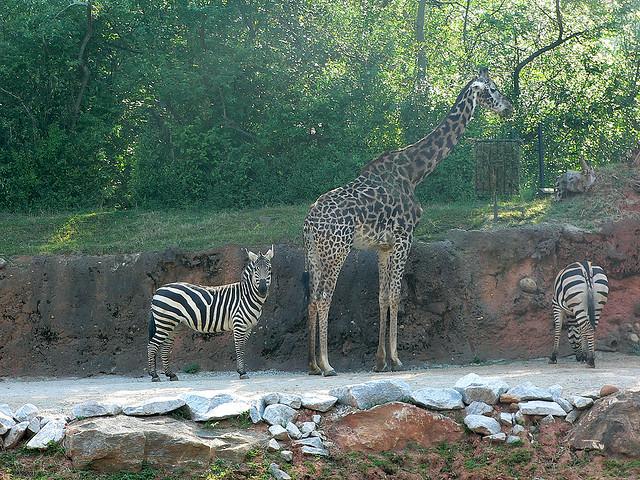Is the zebra taller than the giraffe?
Short answer required. No. How many zebras are in the picture?
Keep it brief. 2. How many different animals are there?
Give a very brief answer. 2. 